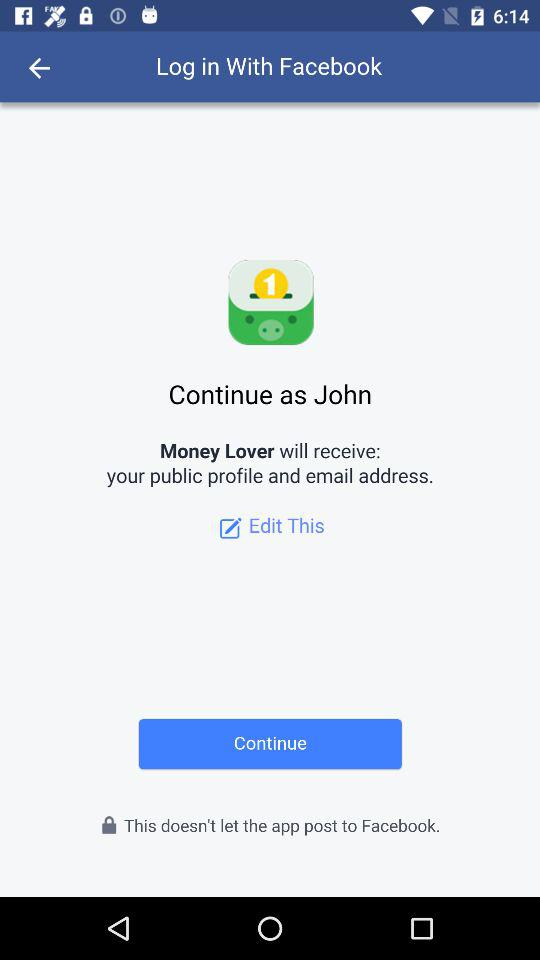What is the name of the user? The name of the user is John. 